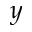Convert formula to latex. <formula><loc_0><loc_0><loc_500><loc_500>y</formula> 